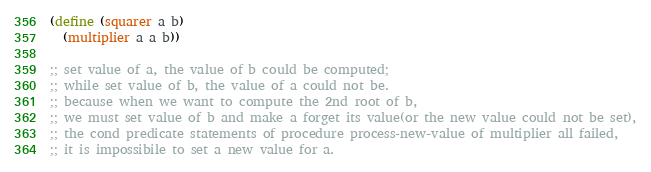<code> <loc_0><loc_0><loc_500><loc_500><_Scheme_>(define (squarer a b)
  (multiplier a a b))

;; set value of a, the value of b could be computed;
;; while set value of b, the value of a could not be.
;; because when we want to compute the 2nd root of b,
;; we must set value of b and make a forget its value(or the new value could not be set),
;; the cond predicate statements of procedure process-new-value of multiplier all failed,
;; it is impossibile to set a new value for a.
</code> 